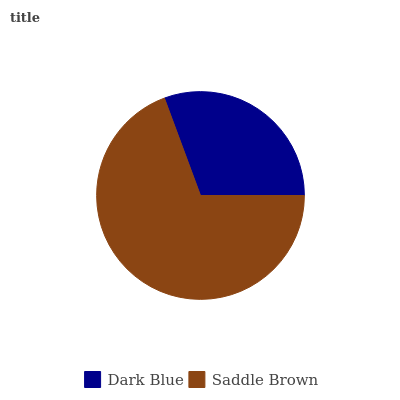Is Dark Blue the minimum?
Answer yes or no. Yes. Is Saddle Brown the maximum?
Answer yes or no. Yes. Is Saddle Brown the minimum?
Answer yes or no. No. Is Saddle Brown greater than Dark Blue?
Answer yes or no. Yes. Is Dark Blue less than Saddle Brown?
Answer yes or no. Yes. Is Dark Blue greater than Saddle Brown?
Answer yes or no. No. Is Saddle Brown less than Dark Blue?
Answer yes or no. No. Is Saddle Brown the high median?
Answer yes or no. Yes. Is Dark Blue the low median?
Answer yes or no. Yes. Is Dark Blue the high median?
Answer yes or no. No. Is Saddle Brown the low median?
Answer yes or no. No. 